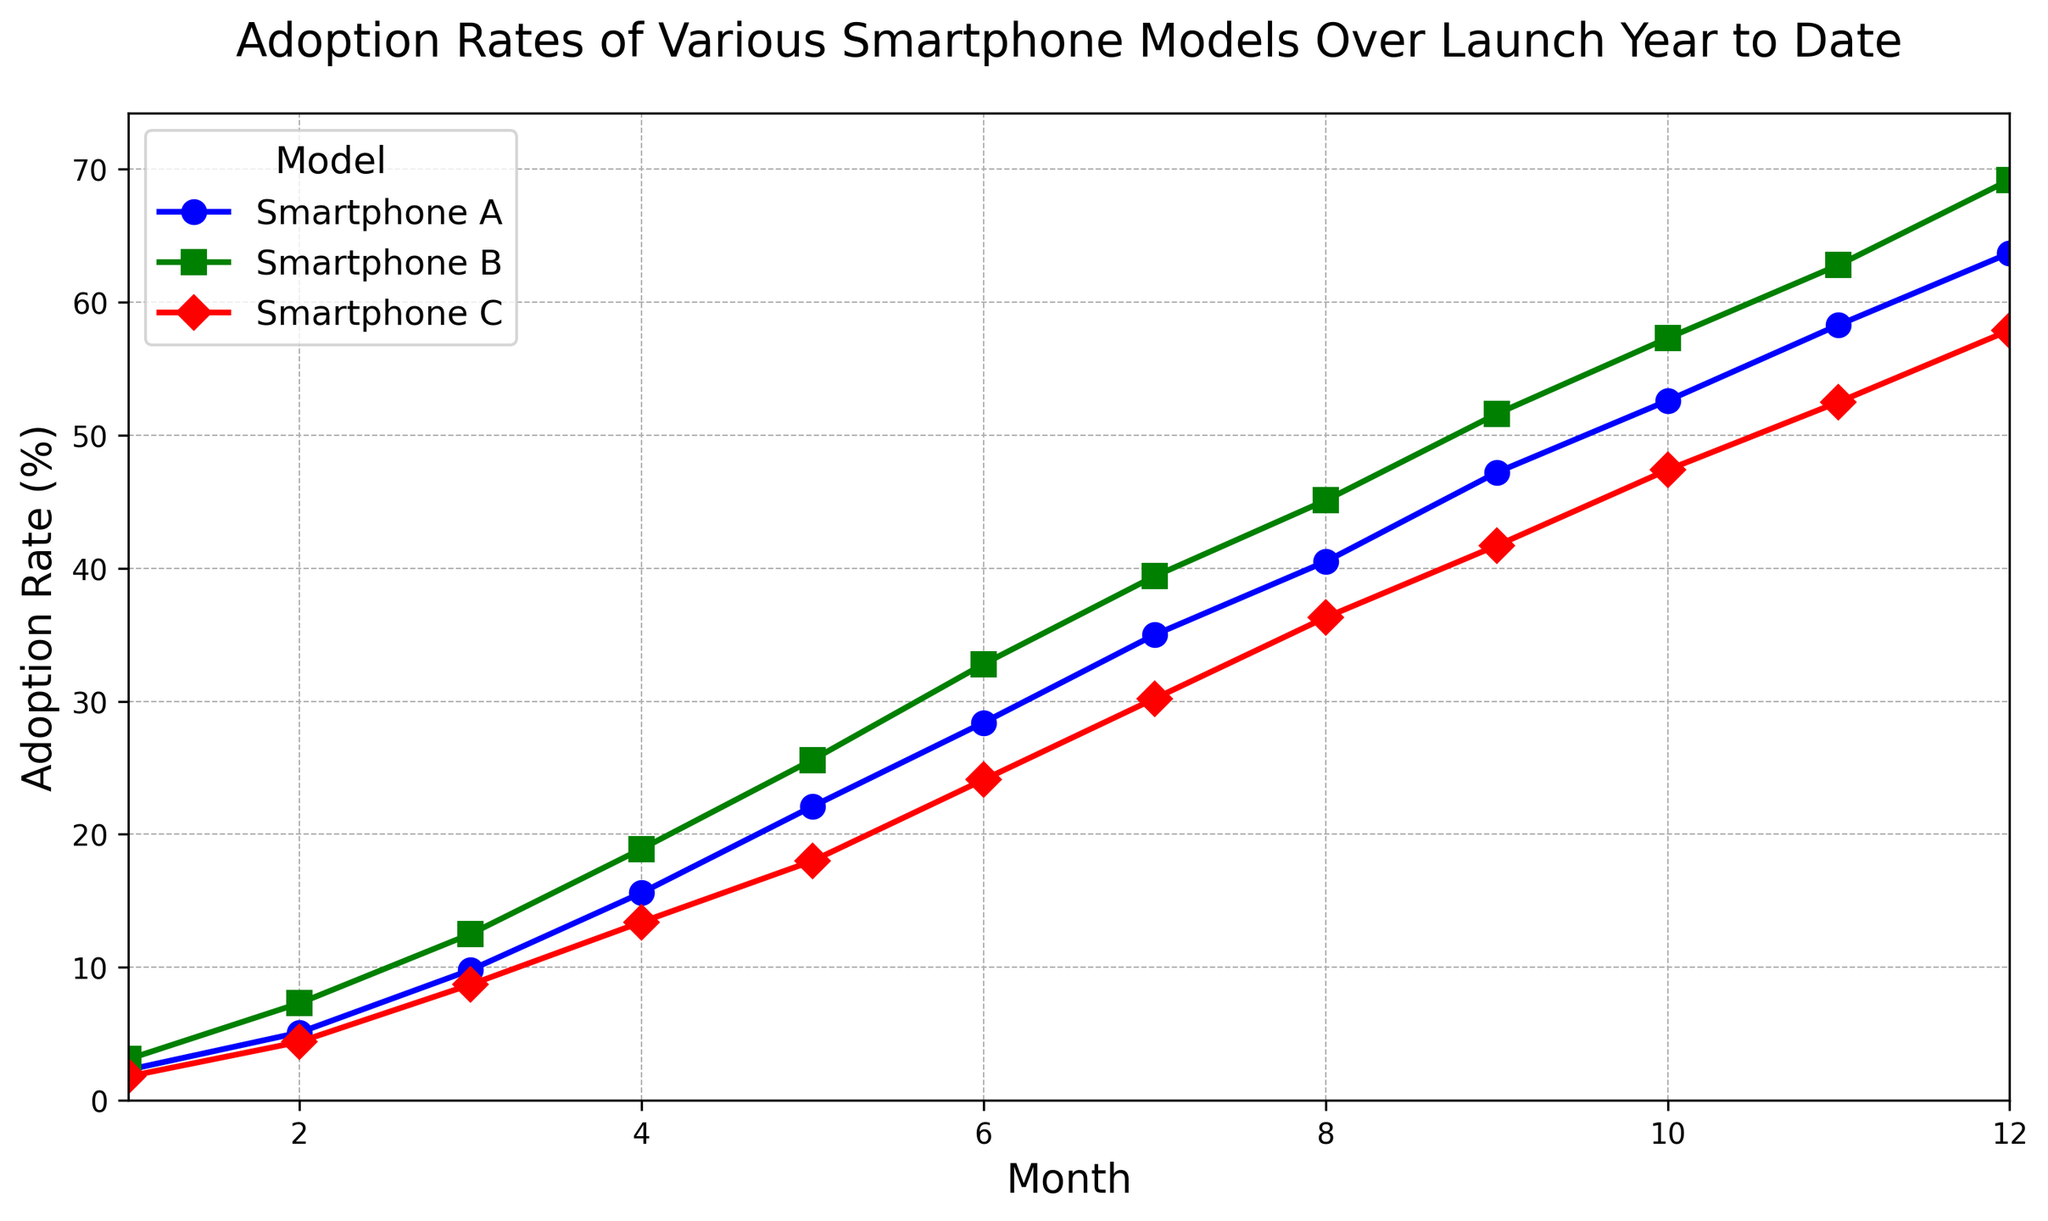What is the average adoption rate of Smartphone B over the first 6 months? Add the adoption rates for each of the first 6 months (3.1, 7.3, 12.5, 18.9, 25.6, 32.8) and then divide by 6. (3.1 + 7.3 + 12.5 + 18.9 + 25.6 + 32.8) / 6 = 100.2 / 6
Answer: 16.7 Which smartphone model had the highest adoption rate in the 10th month? From the plot, in the 10th month, compare the adoption rates of Smartphone A (52.6), Smartphone B (57.3), and Smartphone C (47.4). The highest is Smartphone B.
Answer: Smartphone B What is the difference in adoption rates between Smartphone C and Smartphone A in the 5th month? Find and subtract Smartphone A's rate from Smartphone C's rate in the 5th month: 18.0 - 22.1 = -4.1
Answer: -4.1 In which month does Smartphone A reach an adoption rate of 40% or more? Locate the data points of Smartphone A and find the month where it reaches or exceeds 40%, which is the 8th month (40.5%).
Answer: 8th month By how much did the adoption rate of Smartphone B increase between month 4 and month 7? Subtract the adoption rate in month 4 from the adoption rate in month 7 for Smartphone B: 39.4 - 18.9 = 20.5
Answer: 20.5 If we average the adoption rates of all three smartphones in the 6th month, what would it be? Add the adoption rates of all three smartphones in the 6th month (28.4, 32.8, 24.1) and divide by 3: (28.4 + 32.8 + 24.1) / 3 = 85.3 / 3
Answer: 28.43 How does the adoption trend of Smartphone C compare visually to Smartphone A over the 12 months? Visually, both lines (red for Smartphone C and blue for Smartphone A) show an upward trend, but Smartphone C’s line rises more gradually and reaches a peak of 57.9%, whereas Smartphone A reaches 63.7%.
Answer: Gradual for C, Steeper for A Which model has the steepest adoption rate growth in the first month? Compare the slopes of the lines for each smartphone in the first month. Smartphone B has the highest initial adoption rate starting at 3.1%.
Answer: Smartphone B 